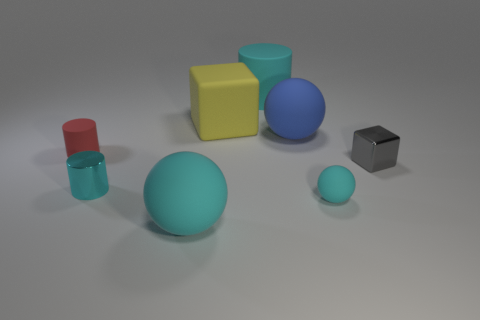Subtract all cyan rubber spheres. How many spheres are left? 1 Add 1 gray metal blocks. How many objects exist? 9 Subtract all blocks. How many objects are left? 6 Subtract all blue spheres. How many spheres are left? 2 Subtract 3 balls. How many balls are left? 0 Add 5 small purple metallic objects. How many small purple metallic objects exist? 5 Subtract 0 red balls. How many objects are left? 8 Subtract all yellow balls. Subtract all gray cylinders. How many balls are left? 3 Subtract all green spheres. How many gray blocks are left? 1 Subtract all small red rubber cylinders. Subtract all large blue matte cylinders. How many objects are left? 7 